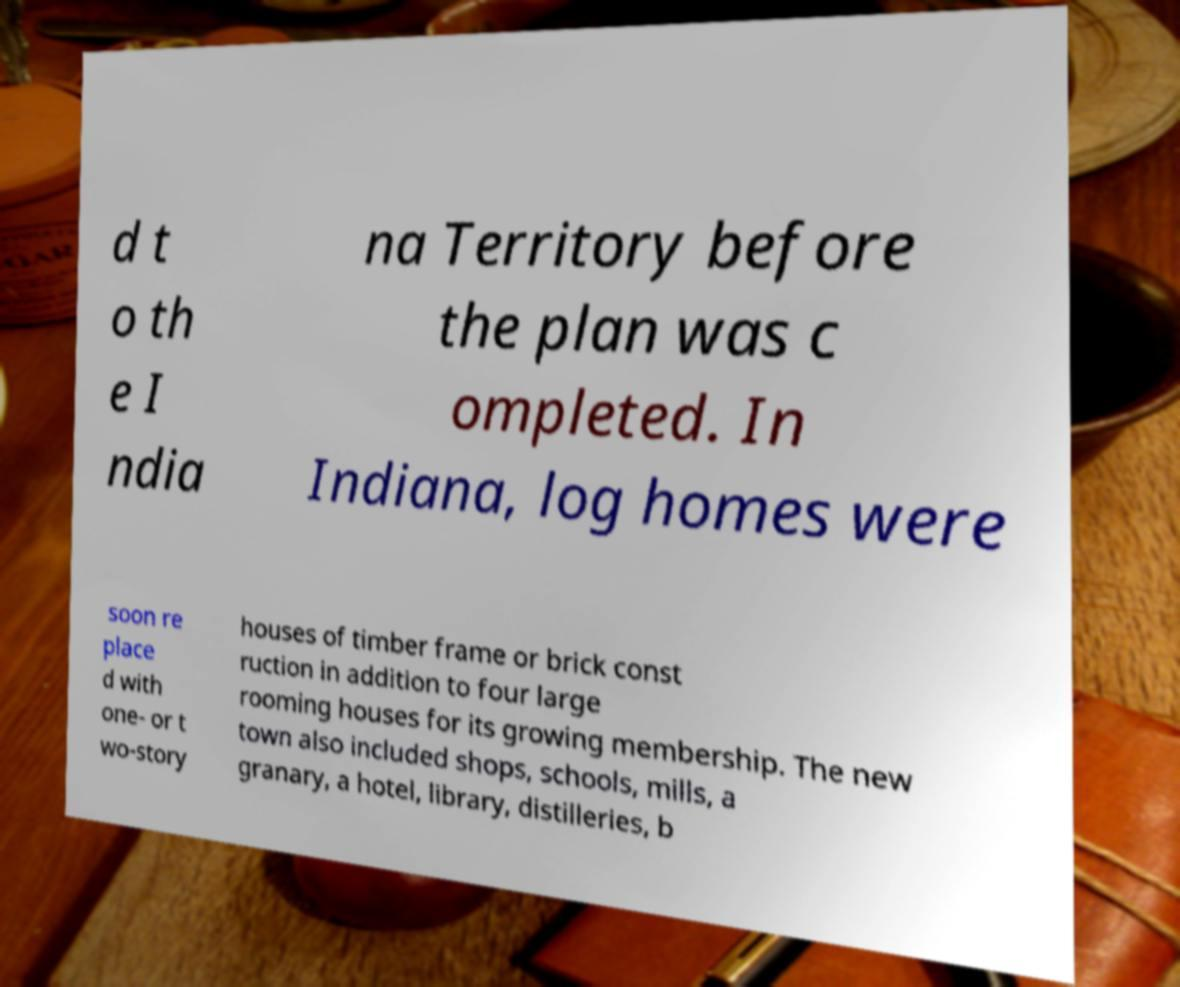Can you read and provide the text displayed in the image?This photo seems to have some interesting text. Can you extract and type it out for me? d t o th e I ndia na Territory before the plan was c ompleted. In Indiana, log homes were soon re place d with one- or t wo-story houses of timber frame or brick const ruction in addition to four large rooming houses for its growing membership. The new town also included shops, schools, mills, a granary, a hotel, library, distilleries, b 